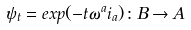Convert formula to latex. <formula><loc_0><loc_0><loc_500><loc_500>\psi _ { t } = e x p ( - t \omega ^ { a } i _ { a } ) \colon B \rightarrow A</formula> 